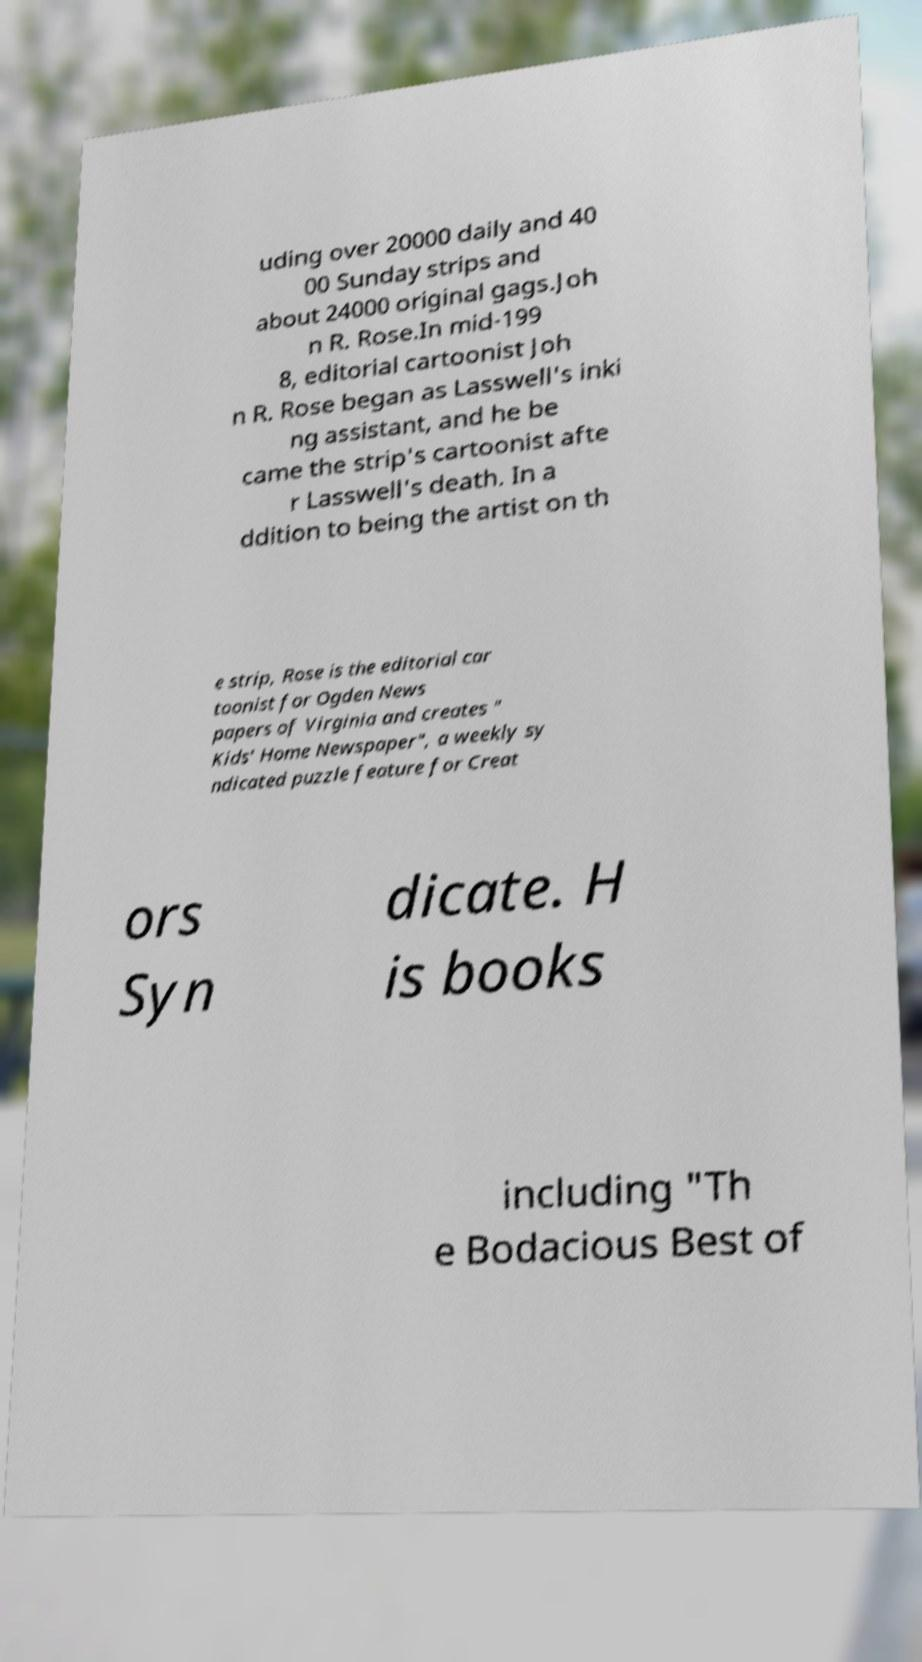I need the written content from this picture converted into text. Can you do that? uding over 20000 daily and 40 00 Sunday strips and about 24000 original gags.Joh n R. Rose.In mid-199 8, editorial cartoonist Joh n R. Rose began as Lasswell's inki ng assistant, and he be came the strip's cartoonist afte r Lasswell's death. In a ddition to being the artist on th e strip, Rose is the editorial car toonist for Ogden News papers of Virginia and creates " Kids' Home Newspaper", a weekly sy ndicated puzzle feature for Creat ors Syn dicate. H is books including "Th e Bodacious Best of 